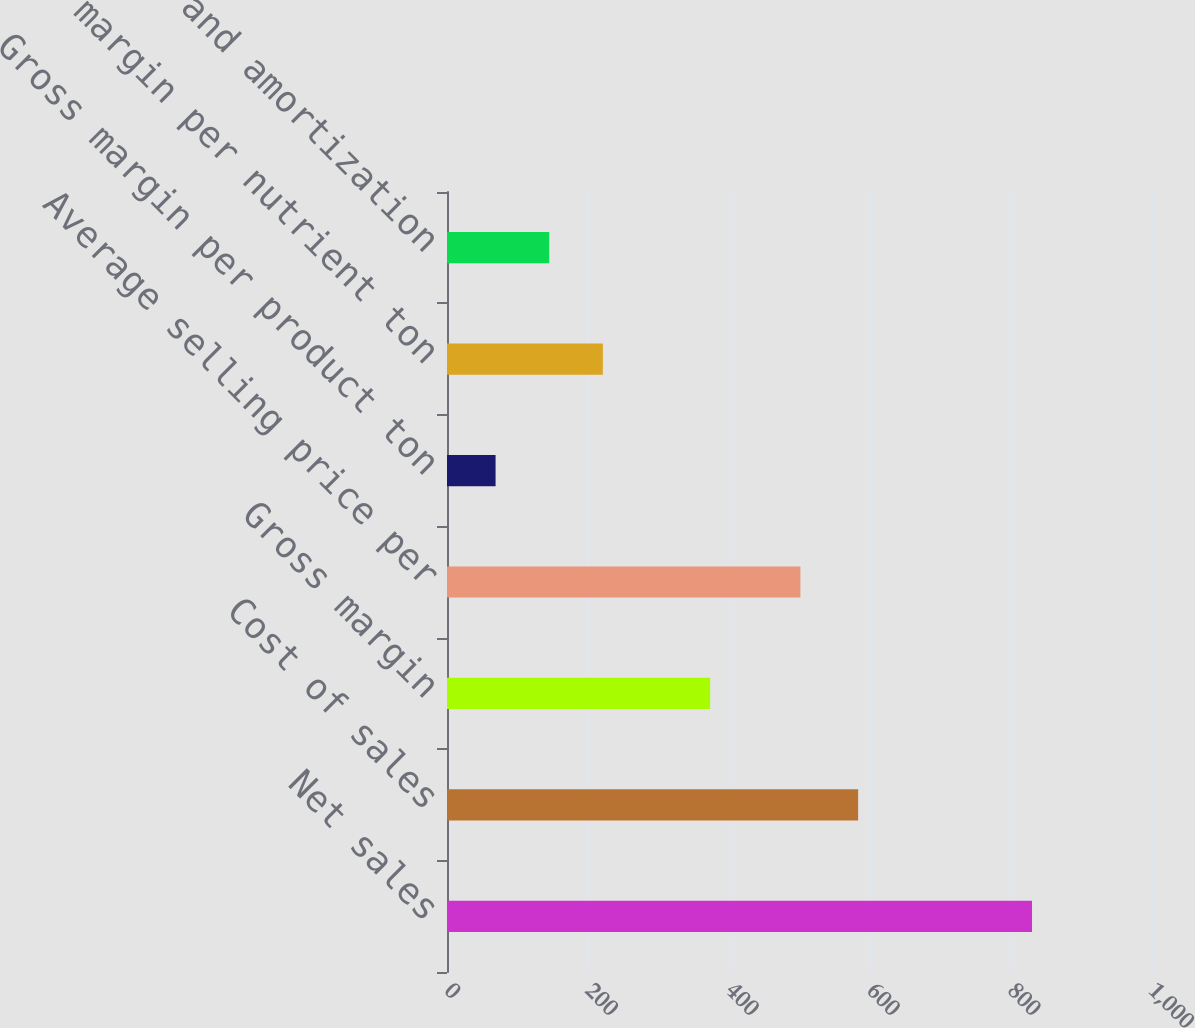Convert chart to OTSL. <chart><loc_0><loc_0><loc_500><loc_500><bar_chart><fcel>Net sales<fcel>Cost of sales<fcel>Gross margin<fcel>Average selling price per<fcel>Gross margin per product ton<fcel>Gross margin per nutrient ton<fcel>Depreciation and amortization<nl><fcel>831<fcel>584<fcel>373.8<fcel>502<fcel>69<fcel>221.4<fcel>145.2<nl></chart> 